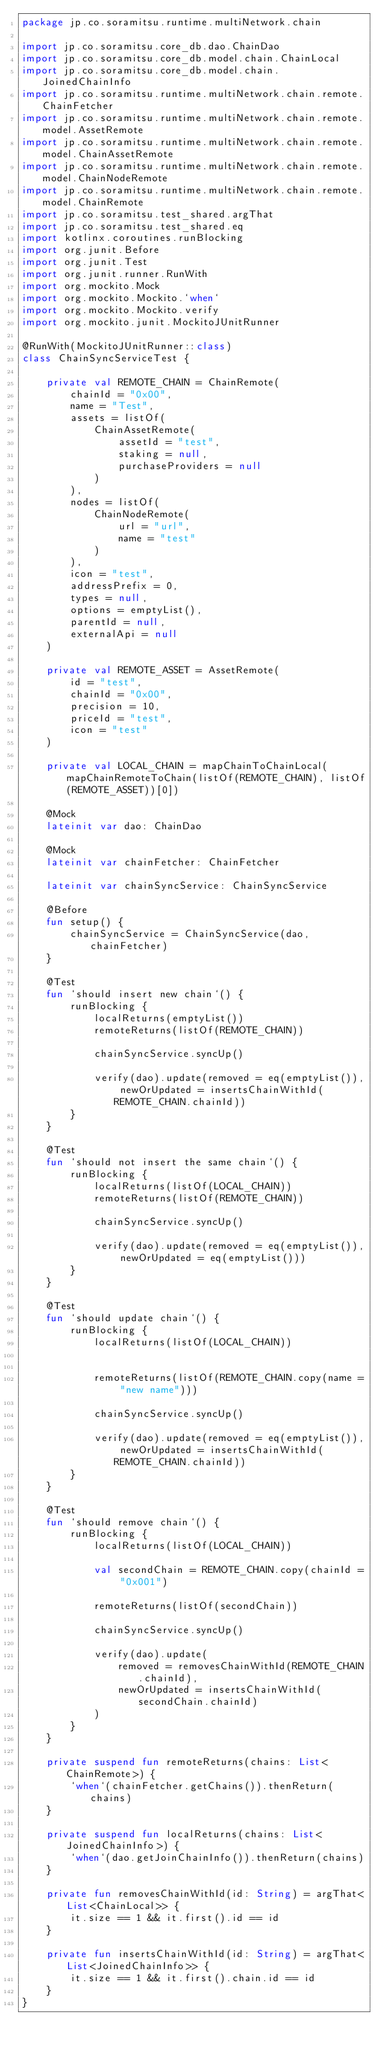Convert code to text. <code><loc_0><loc_0><loc_500><loc_500><_Kotlin_>package jp.co.soramitsu.runtime.multiNetwork.chain

import jp.co.soramitsu.core_db.dao.ChainDao
import jp.co.soramitsu.core_db.model.chain.ChainLocal
import jp.co.soramitsu.core_db.model.chain.JoinedChainInfo
import jp.co.soramitsu.runtime.multiNetwork.chain.remote.ChainFetcher
import jp.co.soramitsu.runtime.multiNetwork.chain.remote.model.AssetRemote
import jp.co.soramitsu.runtime.multiNetwork.chain.remote.model.ChainAssetRemote
import jp.co.soramitsu.runtime.multiNetwork.chain.remote.model.ChainNodeRemote
import jp.co.soramitsu.runtime.multiNetwork.chain.remote.model.ChainRemote
import jp.co.soramitsu.test_shared.argThat
import jp.co.soramitsu.test_shared.eq
import kotlinx.coroutines.runBlocking
import org.junit.Before
import org.junit.Test
import org.junit.runner.RunWith
import org.mockito.Mock
import org.mockito.Mockito.`when`
import org.mockito.Mockito.verify
import org.mockito.junit.MockitoJUnitRunner

@RunWith(MockitoJUnitRunner::class)
class ChainSyncServiceTest {

    private val REMOTE_CHAIN = ChainRemote(
        chainId = "0x00",
        name = "Test",
        assets = listOf(
            ChainAssetRemote(
                assetId = "test",
                staking = null,
                purchaseProviders = null
            )
        ),
        nodes = listOf(
            ChainNodeRemote(
                url = "url",
                name = "test"
            )
        ),
        icon = "test",
        addressPrefix = 0,
        types = null,
        options = emptyList(),
        parentId = null,
        externalApi = null
    )

    private val REMOTE_ASSET = AssetRemote(
        id = "test",
        chainId = "0x00",
        precision = 10,
        priceId = "test",
        icon = "test"
    )

    private val LOCAL_CHAIN = mapChainToChainLocal(mapChainRemoteToChain(listOf(REMOTE_CHAIN), listOf(REMOTE_ASSET))[0])

    @Mock
    lateinit var dao: ChainDao

    @Mock
    lateinit var chainFetcher: ChainFetcher

    lateinit var chainSyncService: ChainSyncService

    @Before
    fun setup() {
        chainSyncService = ChainSyncService(dao, chainFetcher)
    }

    @Test
    fun `should insert new chain`() {
        runBlocking {
            localReturns(emptyList())
            remoteReturns(listOf(REMOTE_CHAIN))

            chainSyncService.syncUp()

            verify(dao).update(removed = eq(emptyList()), newOrUpdated = insertsChainWithId(REMOTE_CHAIN.chainId))
        }
    }

    @Test
    fun `should not insert the same chain`() {
        runBlocking {
            localReturns(listOf(LOCAL_CHAIN))
            remoteReturns(listOf(REMOTE_CHAIN))

            chainSyncService.syncUp()

            verify(dao).update(removed = eq(emptyList()), newOrUpdated = eq(emptyList()))
        }
    }

    @Test
    fun `should update chain`() {
        runBlocking {
            localReturns(listOf(LOCAL_CHAIN))


            remoteReturns(listOf(REMOTE_CHAIN.copy(name = "new name")))

            chainSyncService.syncUp()

            verify(dao).update(removed = eq(emptyList()), newOrUpdated = insertsChainWithId(REMOTE_CHAIN.chainId))
        }
    }

    @Test
    fun `should remove chain`() {
        runBlocking {
            localReturns(listOf(LOCAL_CHAIN))

            val secondChain = REMOTE_CHAIN.copy(chainId = "0x001")

            remoteReturns(listOf(secondChain))

            chainSyncService.syncUp()

            verify(dao).update(
                removed = removesChainWithId(REMOTE_CHAIN.chainId),
                newOrUpdated = insertsChainWithId(secondChain.chainId)
            )
        }
    }

    private suspend fun remoteReturns(chains: List<ChainRemote>) {
        `when`(chainFetcher.getChains()).thenReturn(chains)
    }

    private suspend fun localReturns(chains: List<JoinedChainInfo>) {
        `when`(dao.getJoinChainInfo()).thenReturn(chains)
    }

    private fun removesChainWithId(id: String) = argThat<List<ChainLocal>> {
        it.size == 1 && it.first().id == id
    }

    private fun insertsChainWithId(id: String) = argThat<List<JoinedChainInfo>> {
        it.size == 1 && it.first().chain.id == id
    }
}
</code> 